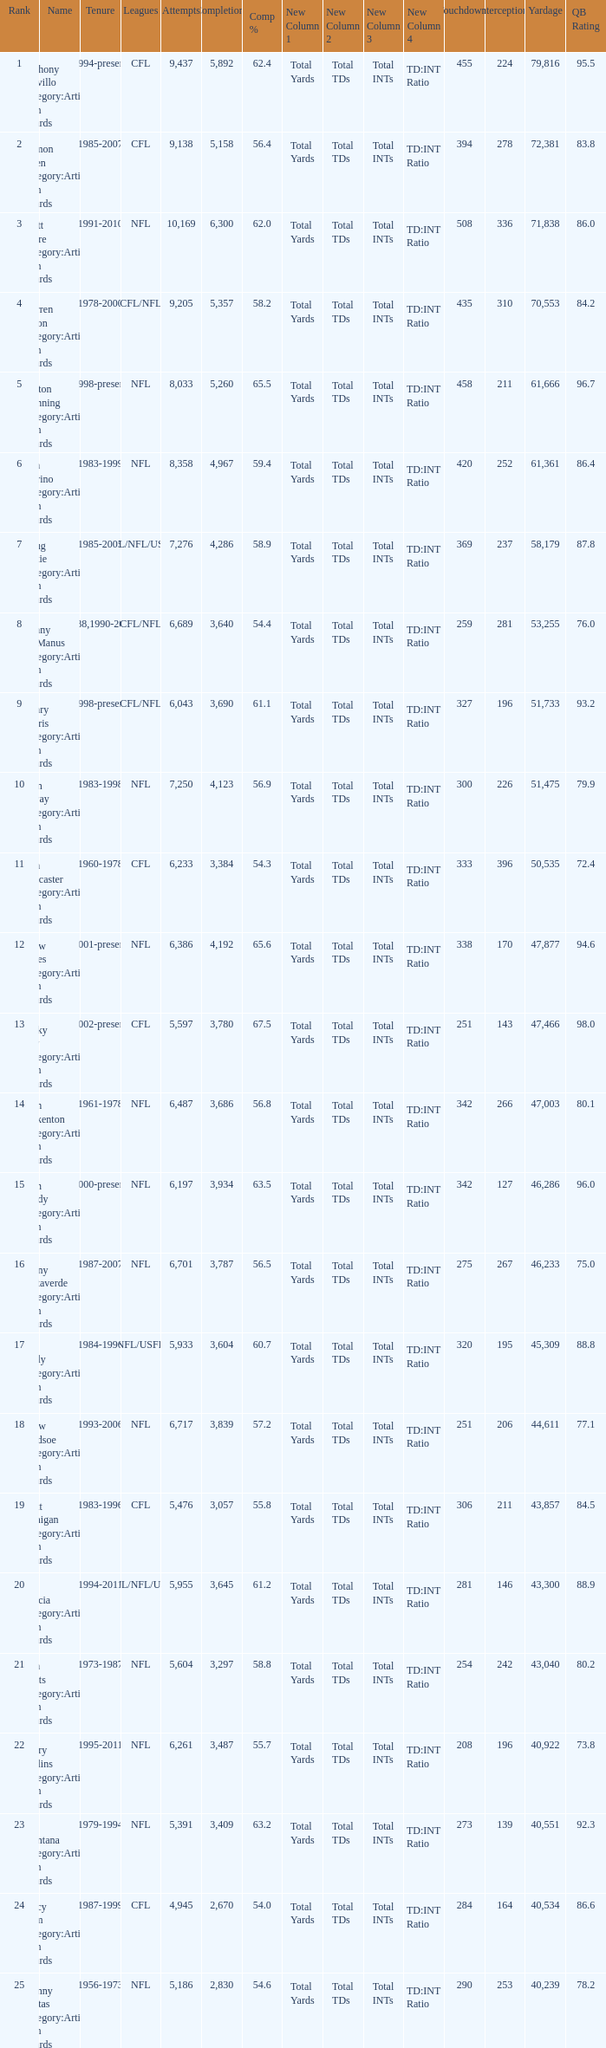What is the comp percentage when there are less than 44,611 in yardage, more than 254 touchdowns, and rank larger than 24? 54.6. 